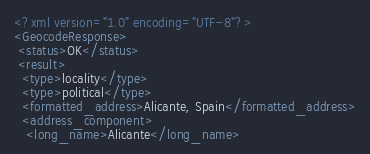Convert code to text. <code><loc_0><loc_0><loc_500><loc_500><_XML_><?xml version="1.0" encoding="UTF-8"?>
<GeocodeResponse>
 <status>OK</status>
 <result>
  <type>locality</type>
  <type>political</type>
  <formatted_address>Alicante, Spain</formatted_address>
  <address_component>
   <long_name>Alicante</long_name></code> 